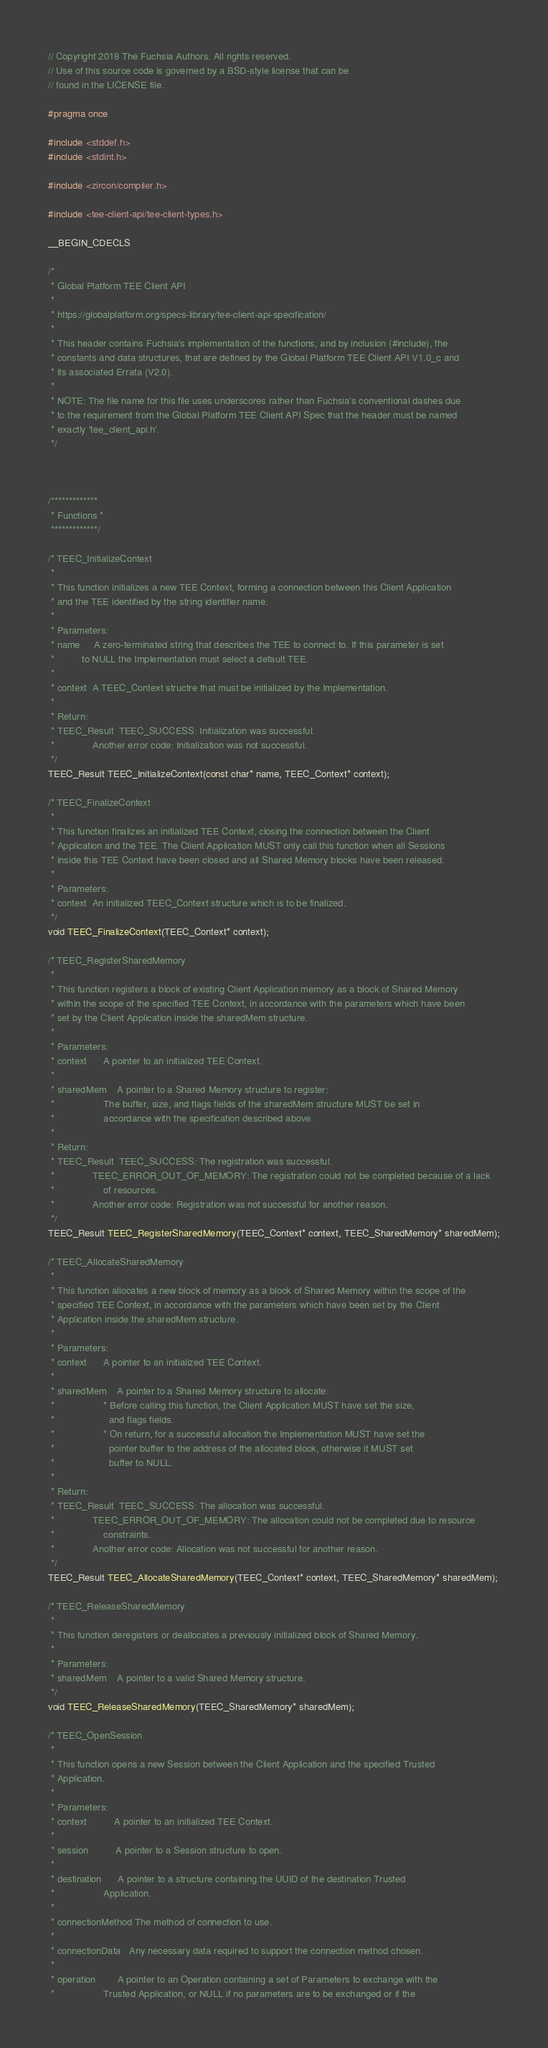<code> <loc_0><loc_0><loc_500><loc_500><_C_>// Copyright 2018 The Fuchsia Authors. All rights reserved.
// Use of this source code is governed by a BSD-style license that can be
// found in the LICENSE file.

#pragma once

#include <stddef.h>
#include <stdint.h>

#include <zircon/compiler.h>

#include <tee-client-api/tee-client-types.h>

__BEGIN_CDECLS

/*
 * Global Platform TEE Client API
 *
 * https://globalplatform.org/specs-library/tee-client-api-specification/
 *
 * This header contains Fuchsia's implementation of the functions, and by inclusion (#include), the
 * constants and data structures, that are defined by the Global Platform TEE Client API V1.0_c and
 * its associated Errata (V2.0).
 *
 * NOTE: The file name for this file uses underscores rather than Fuchsia's conventional dashes due
 * to the requirement from the Global Platform TEE Client API Spec that the header must be named
 * exactly 'tee_client_api.h'.
 */



/*************
 * Functions *
 *************/

/* TEEC_InitializeContext
 *
 * This function initializes a new TEE Context, forming a connection between this Client Application
 * and the TEE identified by the string identifier name.
 *
 * Parameters:
 * name     A zero-terminated string that describes the TEE to connect to. If this parameter is set
 *          to NULL the Implementation must select a default TEE.
 *
 * context  A TEEC_Context structre that must be initialized by the Implementation.
 *
 * Return:
 * TEEC_Result  TEEC_SUCCESS: Initialization was successful.
 *              Another error code: Initialization was not successful.
 */
TEEC_Result TEEC_InitializeContext(const char* name, TEEC_Context* context);

/* TEEC_FinalizeContext
 *
 * This function finalizes an initialized TEE Context, closing the connection between the Client
 * Application and the TEE. The Client Application MUST only call this function when all Sessions
 * inside this TEE Context have been closed and all Shared Memory blocks have been released.
 *
 * Parameters:
 * context  An initialized TEEC_Context structure which is to be finalized.
 */
void TEEC_FinalizeContext(TEEC_Context* context);

/* TEEC_RegisterSharedMemory
 *
 * This function registers a block of existing Client Application memory as a block of Shared Memory
 * within the scope of the specified TEE Context, in accordance with the parameters which have been
 * set by the Client Application inside the sharedMem structure.
 *
 * Parameters:
 * context      A pointer to an initialized TEE Context.
 *
 * sharedMem    A pointer to a Shared Memory structure to register:
 *                  The buffer, size, and flags fields of the sharedMem structure MUST be set in
 *                  accordance with the specification described above.
 *
 * Return:
 * TEEC_Result  TEEC_SUCCESS: The registration was successful.
 *              TEEC_ERROR_OUT_OF_MEMORY: The registration could not be completed because of a lack
 *                  of resources.
 *              Another error code: Registration was not successful for another reason.
 */
TEEC_Result TEEC_RegisterSharedMemory(TEEC_Context* context, TEEC_SharedMemory* sharedMem);

/* TEEC_AllocateSharedMemory
 *
 * This function allocates a new block of memory as a block of Shared Memory within the scope of the
 * specified TEE Context, in accordance with the parameters which have been set by the Client
 * Application inside the sharedMem structure.
 *
 * Parameters:
 * context      A pointer to an initialized TEE Context.
 *
 * sharedMem    A pointer to a Shared Memory structure to allocate:
 *                  * Before calling this function, the Client Application MUST have set the size,
 *                    and flags fields.
 *                  * On return, for a successful allocation the Implementation MUST have set the
 *                    pointer buffer to the address of the allocated block, otherwise it MUST set
 *                    buffer to NULL.
 *
 * Return:
 * TEEC_Result  TEEC_SUCCESS: The allocation was successful.
 *              TEEC_ERROR_OUT_OF_MEMORY: The allocation could not be completed due to resource
 *                  constraints.
 *              Another error code: Allocation was not successful for another reason.
 */
TEEC_Result TEEC_AllocateSharedMemory(TEEC_Context* context, TEEC_SharedMemory* sharedMem);

/* TEEC_ReleaseSharedMemory
 *
 * This function deregisters or deallocates a previously initialized block of Shared Memory.
 *
 * Parameters:
 * sharedMem    A pointer to a valid Shared Memory structure.
 */
void TEEC_ReleaseSharedMemory(TEEC_SharedMemory* sharedMem);

/* TEEC_OpenSession
 *
 * This function opens a new Session between the Client Application and the specified Trusted
 * Application.
 *
 * Parameters:
 * context          A pointer to an initialized TEE Context.
 *
 * session          A pointer to a Session structure to open.
 *
 * destination      A pointer to a structure containing the UUID of the destination Trusted
 *                  Application.
 *
 * connectionMethod The method of connection to use.
 *
 * connectionData   Any necessary data required to support the connection method chosen.
 *
 * operation        A pointer to an Operation containing a set of Parameters to exchange with the
 *                  Trusted Application, or NULL if no parameters are to be exchanged or if the</code> 